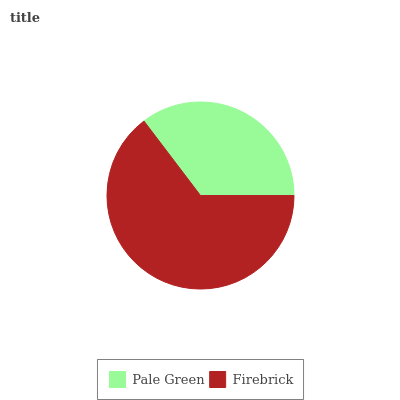Is Pale Green the minimum?
Answer yes or no. Yes. Is Firebrick the maximum?
Answer yes or no. Yes. Is Firebrick the minimum?
Answer yes or no. No. Is Firebrick greater than Pale Green?
Answer yes or no. Yes. Is Pale Green less than Firebrick?
Answer yes or no. Yes. Is Pale Green greater than Firebrick?
Answer yes or no. No. Is Firebrick less than Pale Green?
Answer yes or no. No. Is Firebrick the high median?
Answer yes or no. Yes. Is Pale Green the low median?
Answer yes or no. Yes. Is Pale Green the high median?
Answer yes or no. No. Is Firebrick the low median?
Answer yes or no. No. 